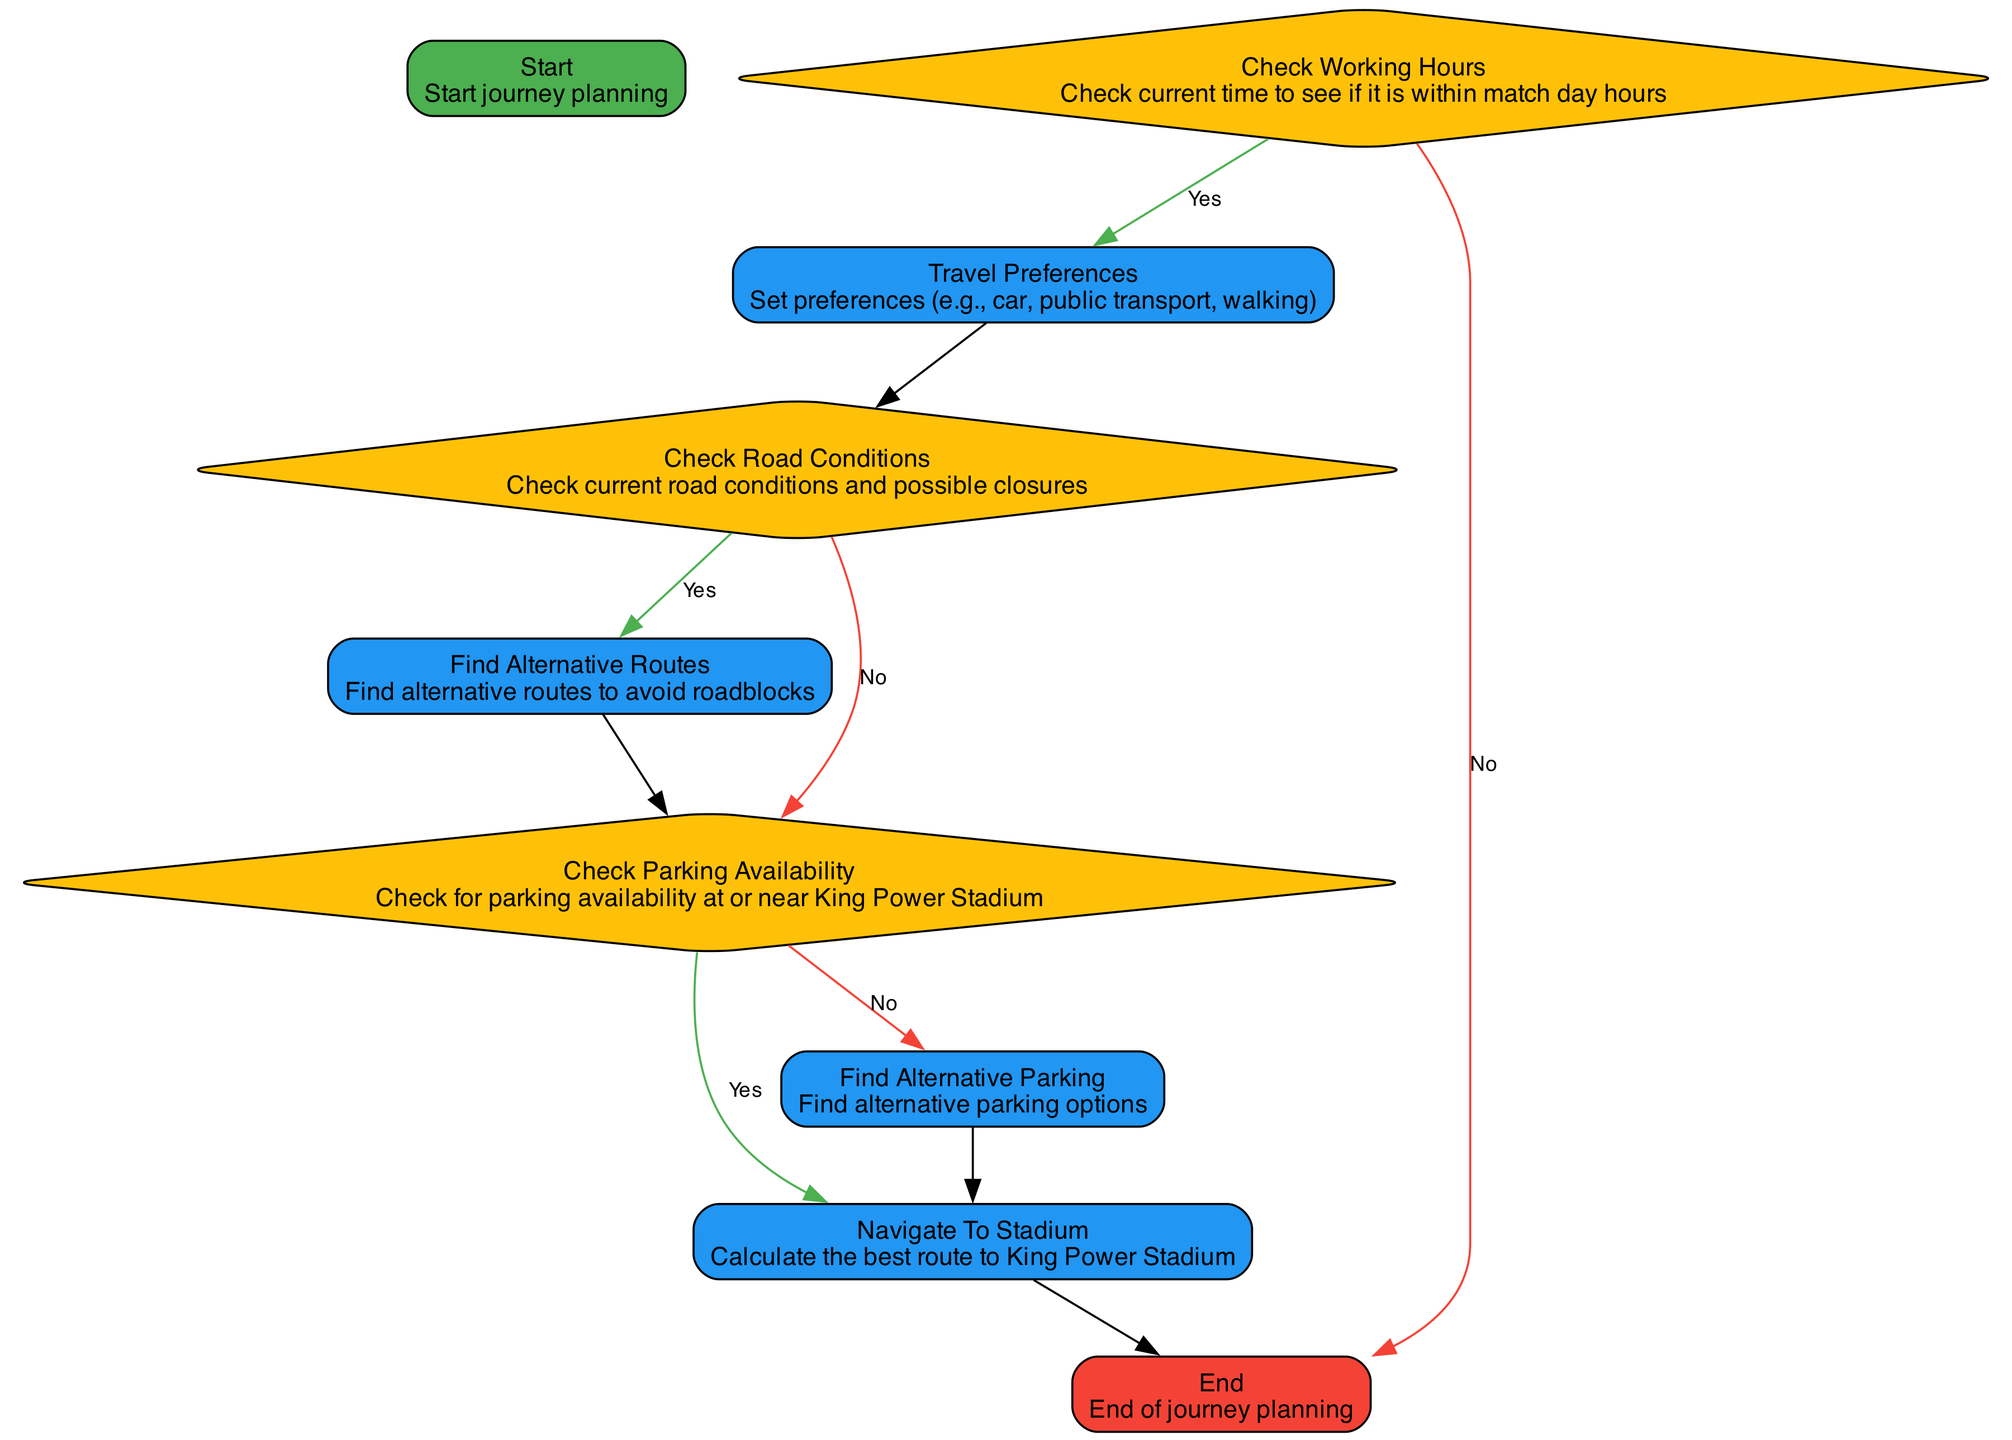What is the starting point of the journey planning? The starting point is defined as "Start journey planning," which initiates the flow of the diagram.
Answer: Start journey planning What happens if the current time is not within match day hours? If the current time is not within match day hours, the flowchart directs to the "end" node, indicating the end of journey planning.
Answer: End What decision comes after checking road conditions? After checking road conditions, the next decision is whether to check for parking availability or find alternative routes based on the current road conditions.
Answer: Check parking availability What process follows finding alternative parking? After finding alternative parking, the next process is to navigate to the stadium, which is responsible for determining the best route to the King Power Stadium.
Answer: Navigate to stadium How many processes are in this flowchart? The flowchart contains four distinct process nodes: travel preferences, find alternative routes, find alternative parking, and navigate to the stadium.
Answer: Four What colors represent decision nodes in the diagram? In the diagram, the color representing decision nodes is yellow, which is designated for decision-type nodes.
Answer: Yellow What is the outcome if parking availability is found? If parking availability is found, the outcome is to navigate to the stadium, which indicates the next step in journey planning involves calculating the best route.
Answer: Navigate to stadium Which node does the journey planning terminate at? The journey planning terminates at the "end" node, which signifies the conclusion of the routing process.
Answer: End What type of node is "check working hours"? The node "check working hours" is classified as a decision node, as it determines the flow based on whether it is match day hours or not.
Answer: Decision node 